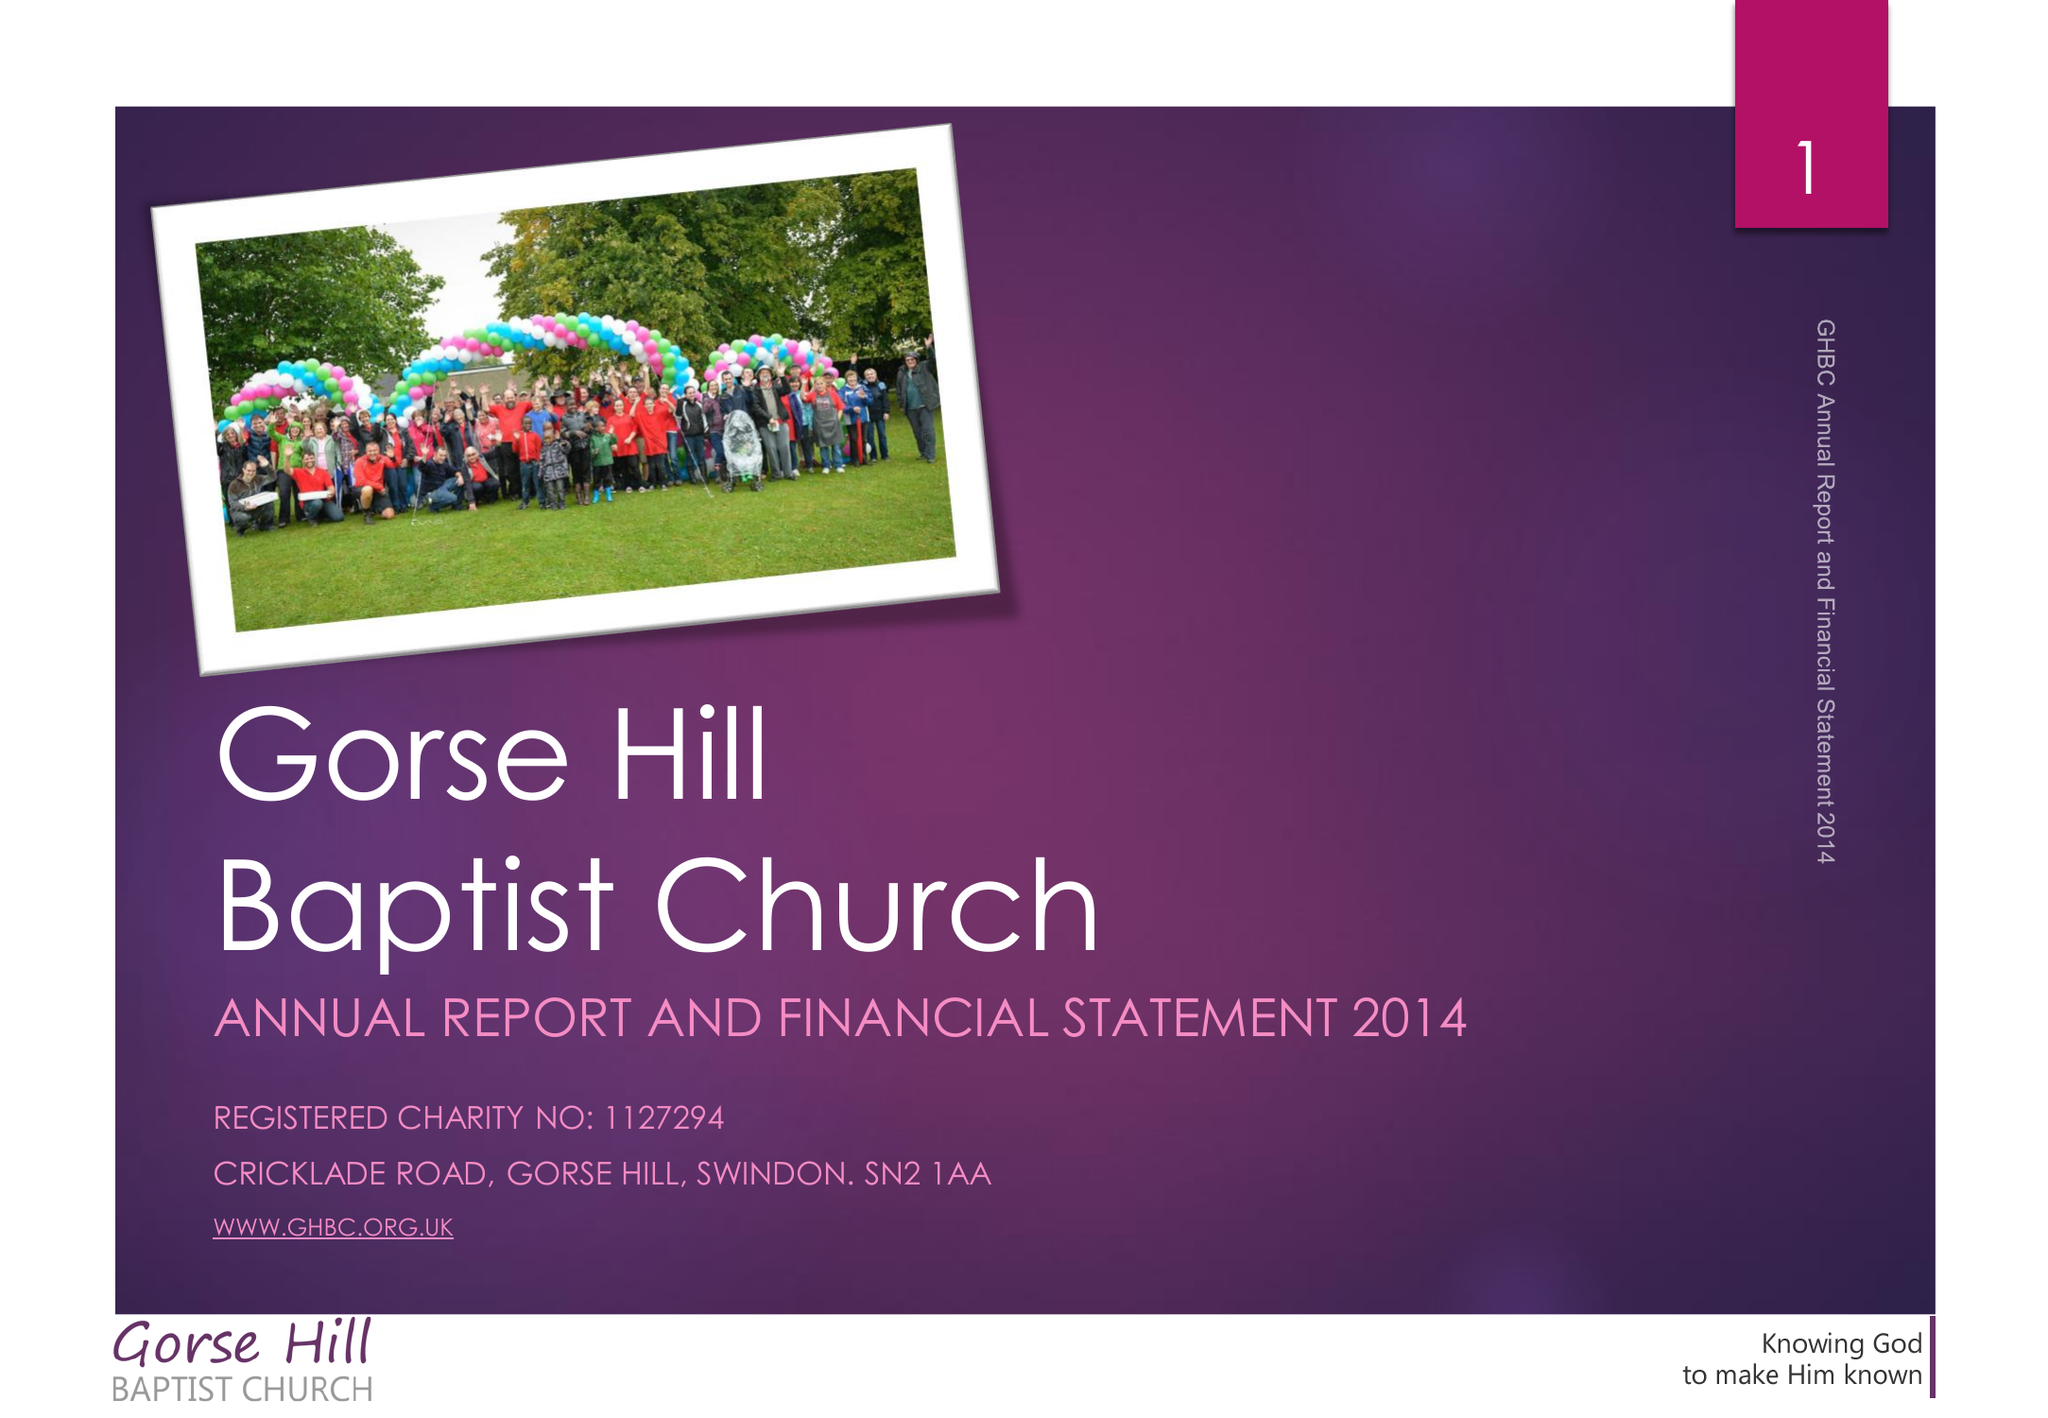What is the value for the charity_name?
Answer the question using a single word or phrase. Gorse Hill Baptist Church 